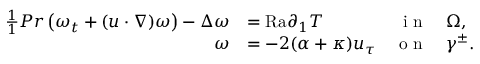Convert formula to latex. <formula><loc_0><loc_0><loc_500><loc_500>\begin{array} { r l r l } { \frac { 1 } { 1 } { P r } \left ( \omega _ { t } + ( u \cdot \nabla ) \omega \right ) - \Delta \omega } & { = { R a } \partial _ { 1 } T } & { i n } & { \Omega , } \\ { \omega } & { = - 2 ( \alpha + \kappa ) u _ { \tau } } & { o n } & { \gamma ^ { \pm } . } \end{array}</formula> 